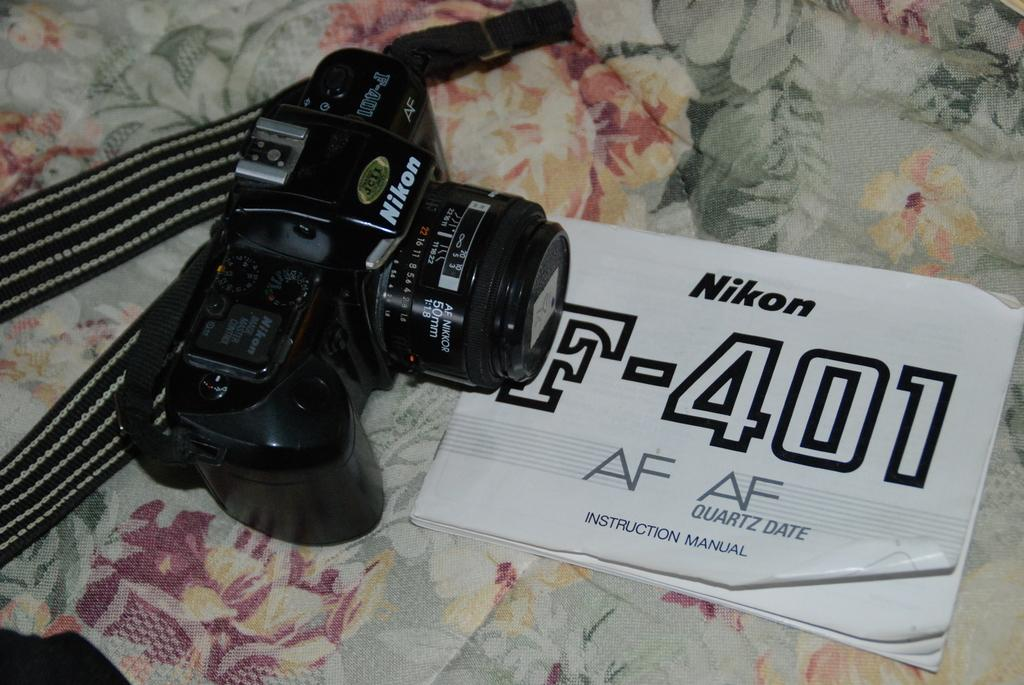What is the main object in the image? There is a camera in the image. What other object is present in the image? There is a book in the image. How are the camera and book positioned in relation to each other? The book is placed in front of the camera. What is the surface on which the camera and book are placed? The camera and book are on a cloth. What type of soap is being used to clean the camera in the image? There is no soap or cleaning activity present in the image; it only shows a camera and a book placed on a cloth. 